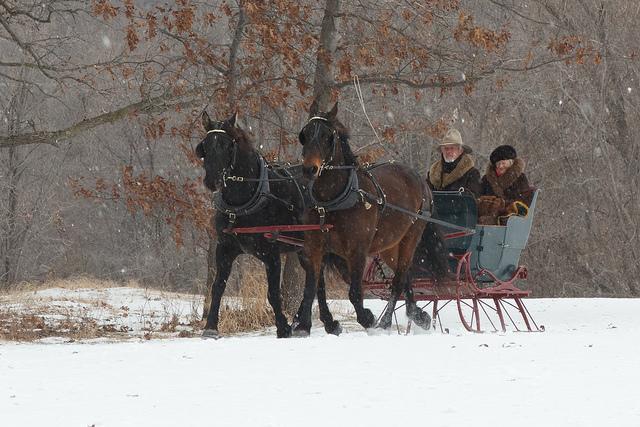How many horses are there?
Give a very brief answer. 2. How many horses are pictured?
Give a very brief answer. 2. How many people are in this scene?
Give a very brief answer. 2. How many animals are there?
Give a very brief answer. 2. How many people are riding on this sled?
Give a very brief answer. 2. 